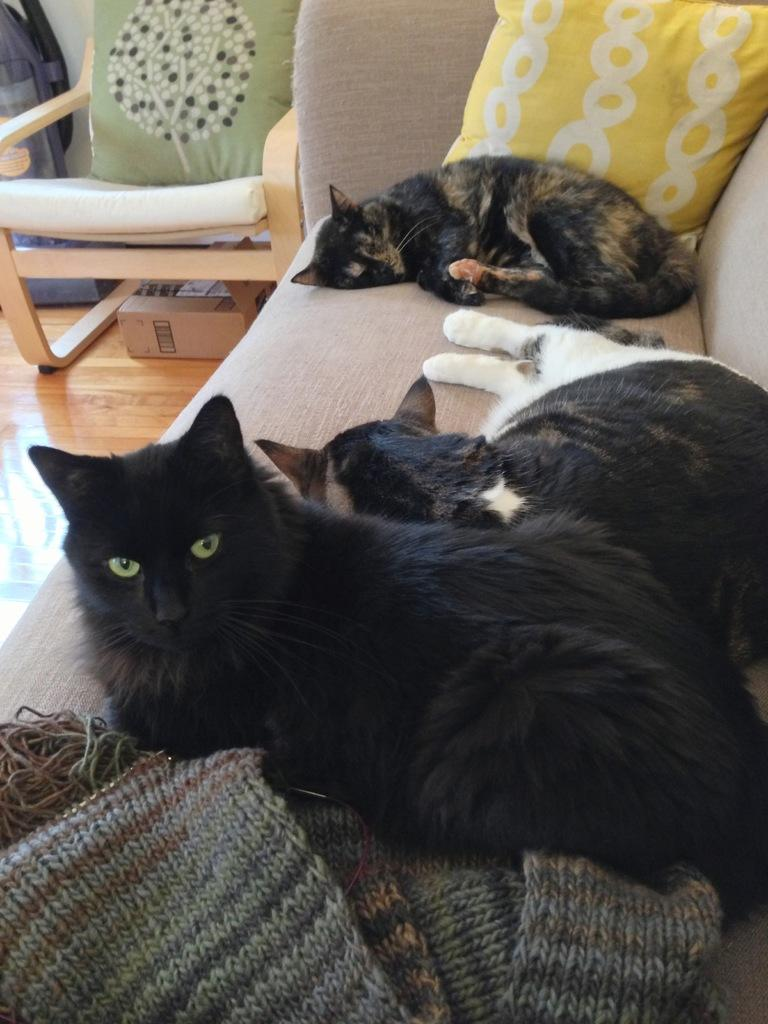How many cats are present in the image? There are three cats in the image. What are the cats doing in the image? The cats are lying on a sofa. Can you describe any other furniture in the image? There is a chair with a green pillow in the image. Where is the chair located in the image? The chair is located towards the left top of the image. What type of science experiment can be seen being conducted on the cats in the image? There is no science experiment or any indication of one being conducted on the cats in the image. 